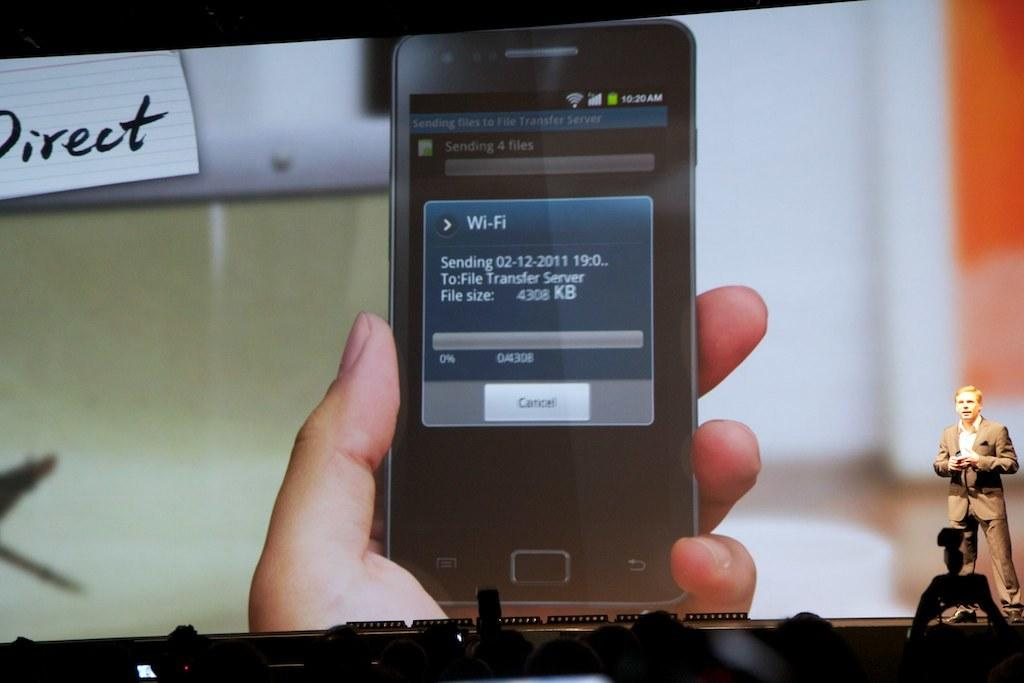<image>
Offer a succinct explanation of the picture presented. Fingers holding a cell phone with the words wifi on the screen of it. 